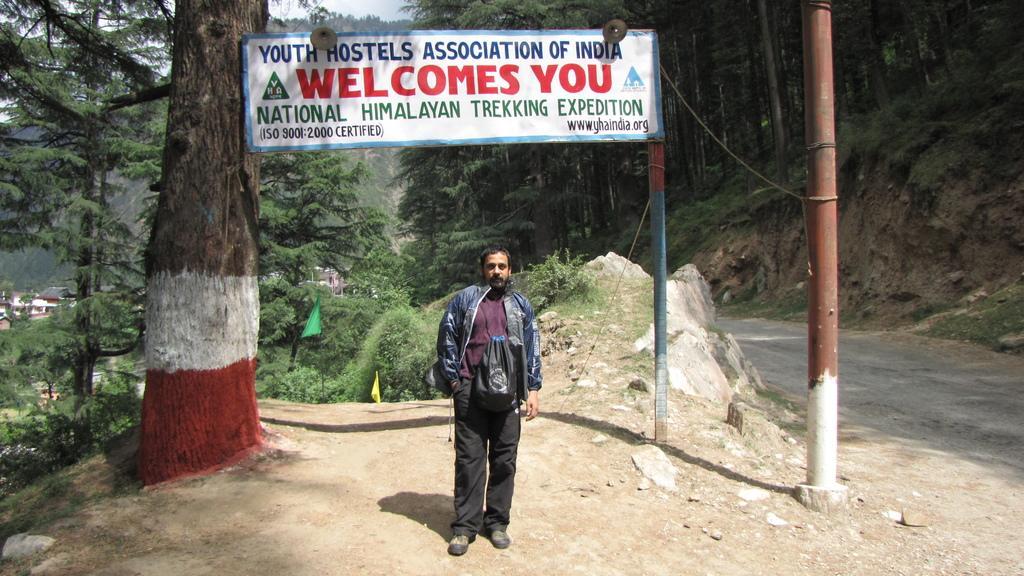Could you give a brief overview of what you see in this image? In this image we can see a man. He is wearing a jacket and a black trouser. Here we can see the bag on his neck. Here we can see the trunk of a tree on the left side. Here we can see the pole and road on the right side. Here we can see the welcome hoarding board. Here we can see the trees on the left side and the right side as well. In the background, we can see the houses. 